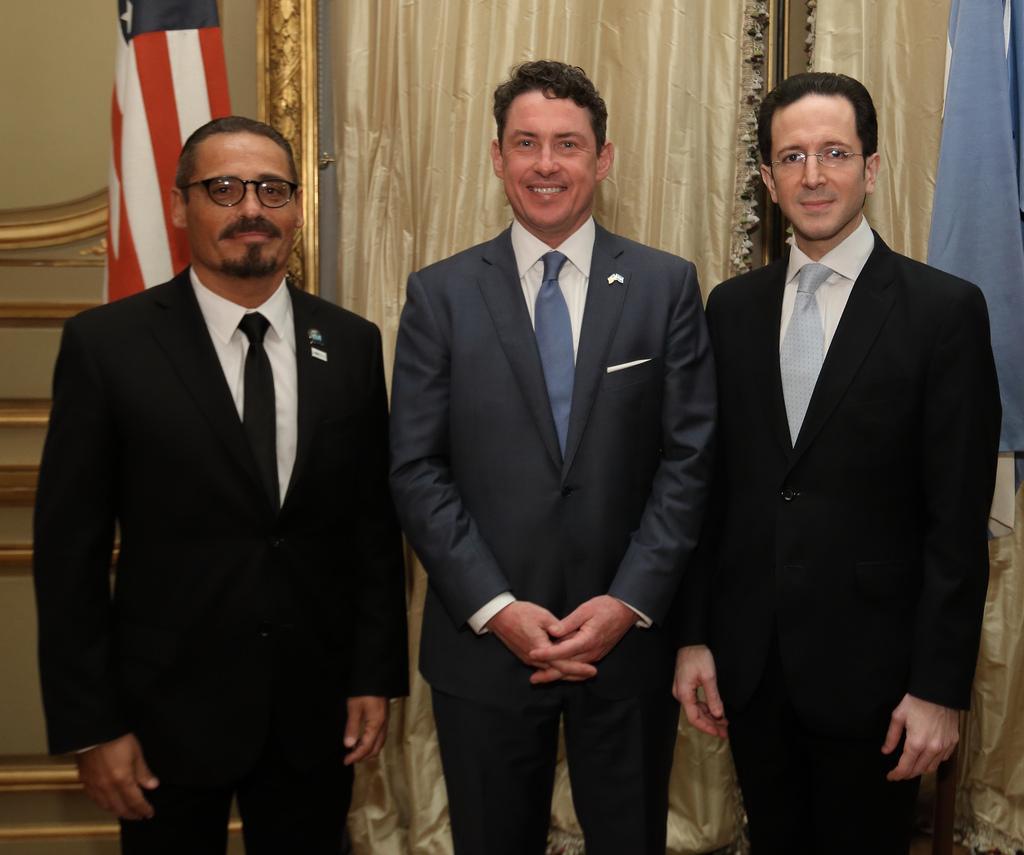Can you describe this image briefly? In the foreground of this picture we can see the three persons wearing suits, smiling and standing on the ground. In the background we can see the curtains and a flag. 